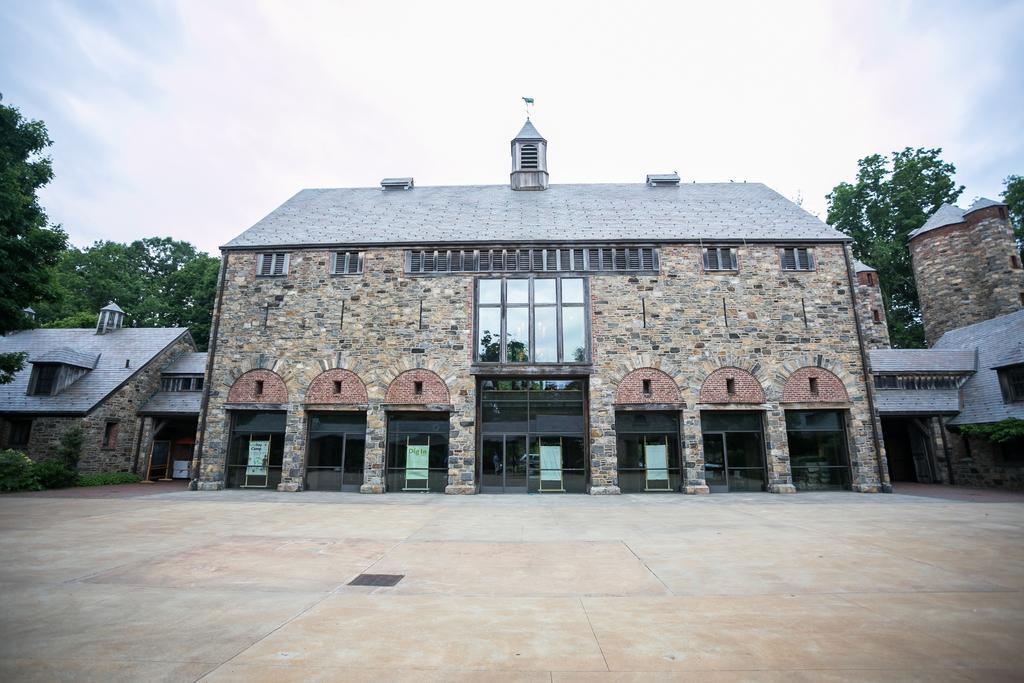Describe this image in one or two sentences. In this image we can see floor, buildings, roofs, windows, hoardings on the stands, trees, roofs, glass doors and clouds in the sky. 